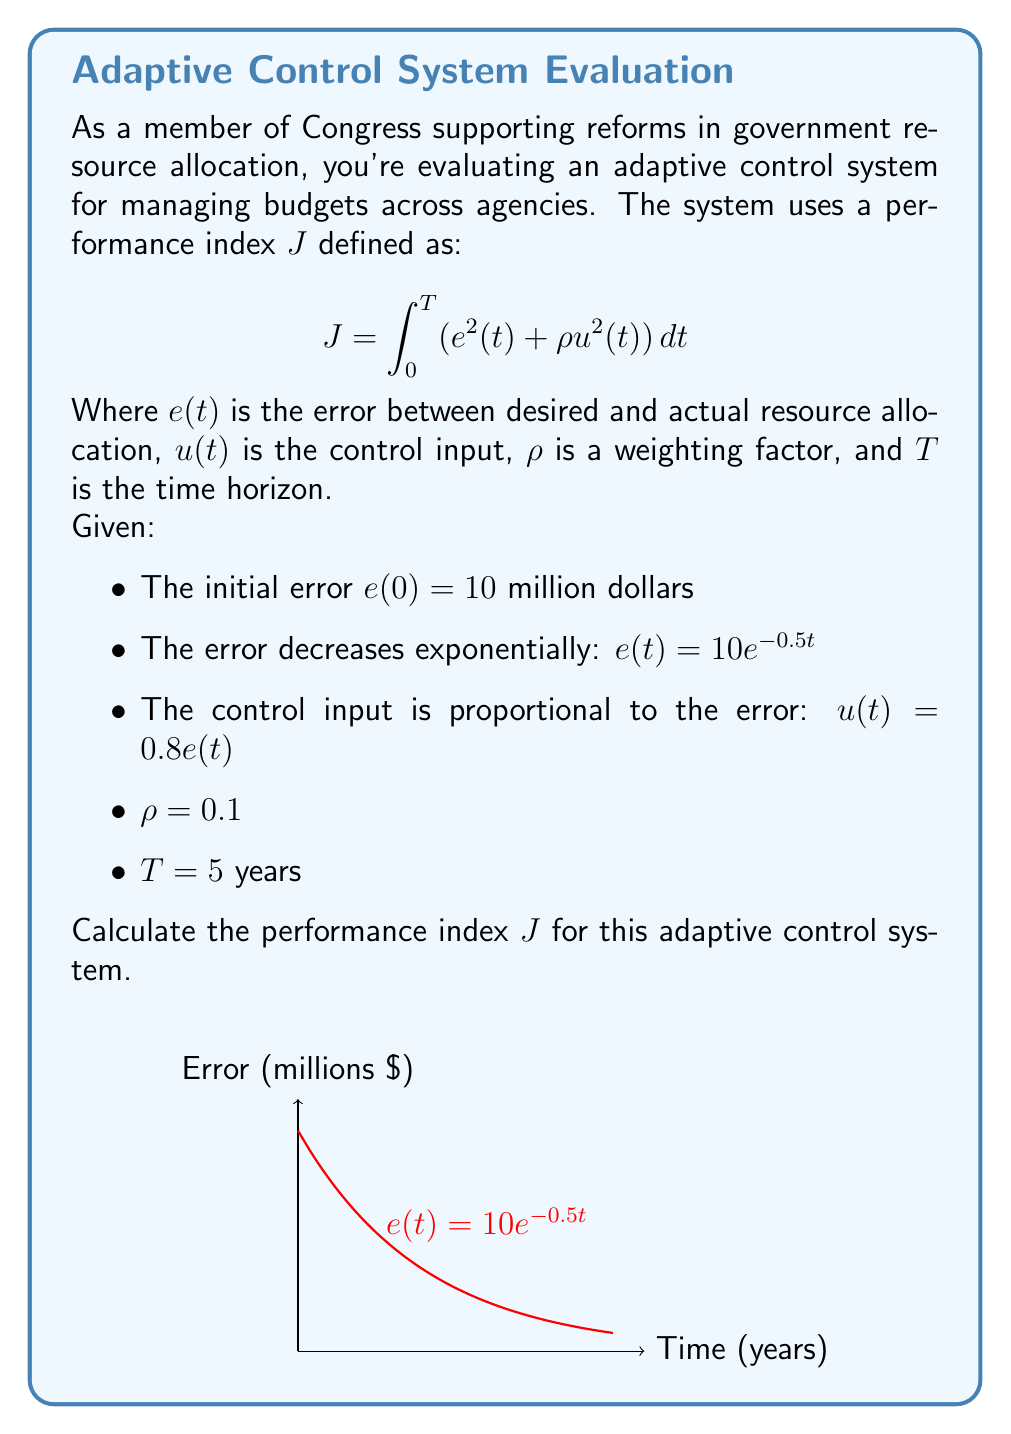Solve this math problem. Let's approach this step-by-step:

1) We need to evaluate the integral:
   $$J = \int_0^5 (e^2(t) + \rho u^2(t)) dt$$

2) Substitute the given functions and values:
   $$J = \int_0^5 ((10e^{-0.5t})^2 + 0.1(0.8 \cdot 10e^{-0.5t})^2) dt$$

3) Simplify:
   $$J = \int_0^5 (100e^{-t} + 0.1 \cdot 64e^{-t}) dt$$
   $$J = \int_0^5 (100e^{-t} + 6.4e^{-t}) dt$$
   $$J = \int_0^5 106.4e^{-t} dt$$

4) Evaluate the integral:
   $$J = -106.4e^{-t} \bigg|_0^5$$
   $$J = -106.4(e^{-5} - e^0)$$
   $$J = -106.4(e^{-5} - 1)$$

5) Calculate the final value:
   $$J = 106.4 - 106.4e^{-5}$$
   $$J \approx 106.4 - 0.7 = 105.7$$

The performance index $J$ is approximately 105.7 million dollars squared-years.
Answer: $J \approx 105.7$ million dollars squared-years 